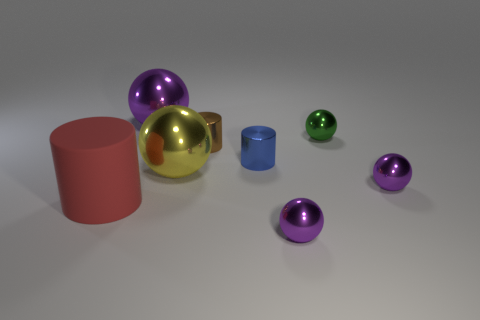Subtract all big cylinders. How many cylinders are left? 2 Add 1 tiny brown matte objects. How many objects exist? 9 Subtract 4 spheres. How many spheres are left? 1 Subtract all red cylinders. How many purple spheres are left? 3 Subtract all purple spheres. How many spheres are left? 2 Subtract 0 green cylinders. How many objects are left? 8 Subtract all cylinders. How many objects are left? 5 Subtract all red spheres. Subtract all purple cylinders. How many spheres are left? 5 Subtract all large red rubber things. Subtract all yellow metallic objects. How many objects are left? 6 Add 4 tiny blue things. How many tiny blue things are left? 5 